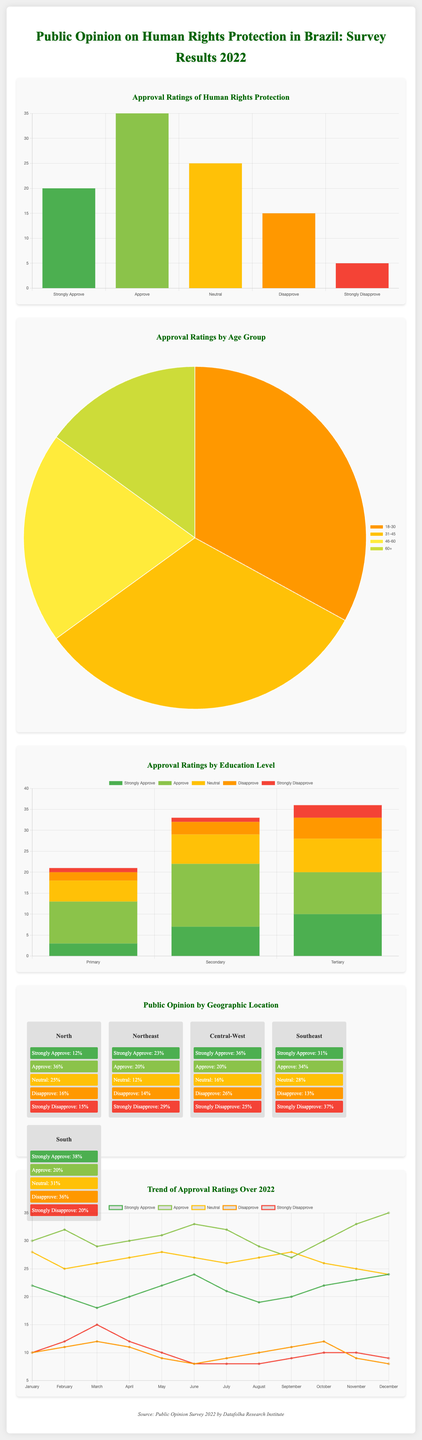What percentage of respondents strongly approve of human rights protection? The percentage of respondents who strongly approve is depicted in the approval ratings chart, showing 20%.
Answer: 20% What age group has the highest percentage of approval ratings? The pie chart indicates that the 18-30 age group has the highest percentage of approval ratings at 33%.
Answer: 18-30 How many respondents with a tertiary education strongly approve of human rights protection? The bar chart under education level shows that 10 respondents with tertiary education strongly approve.
Answer: 10 Which region likely shows the lowest approval rating based on the map chart representation? The representation of opinions by geographic location suggests that specific regions may have lower ratings but doesn't give exact figures; it requires further analysis.
Answer: Not specified What was the strongest approval rating trend in July? The trend chart indicates that in July, the strongest approval rating was for "Strongly Approve" at 21%.
Answer: 21% What was the monthly approval rating for those who "Disapprove" in October? The trend chart for October indicates that the disapproval rating was 12%.
Answer: 12% How many demographic categories are analyzed in the infographic? The infographic provides data for three demographic categories: age, education level, and geographic location.
Answer: Three What is the total percentage of respondents who either approve or strongly approve of human rights protection? The approval ratings chart shows the combined total for approve (35%) and strongly approve (20%), adding up to 55%.
Answer: 55% What color represents the category of "Strongly Disapprove" in the charts? The approval ratings chart uses the color red to represent "Strongly Disapprove."
Answer: Red 